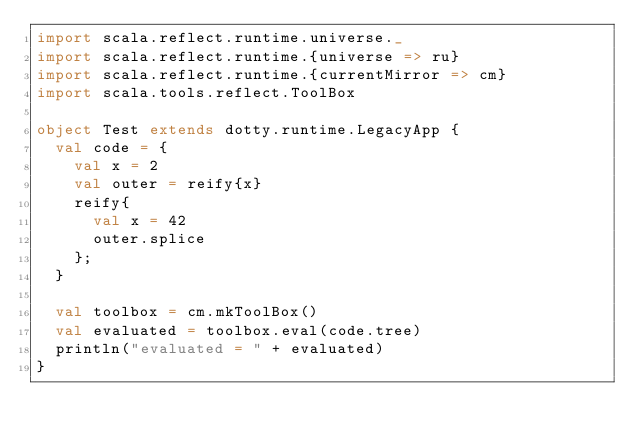Convert code to text. <code><loc_0><loc_0><loc_500><loc_500><_Scala_>import scala.reflect.runtime.universe._
import scala.reflect.runtime.{universe => ru}
import scala.reflect.runtime.{currentMirror => cm}
import scala.tools.reflect.ToolBox

object Test extends dotty.runtime.LegacyApp {
  val code = {
    val x = 2
    val outer = reify{x}
    reify{
      val x = 42
      outer.splice
    };
  }

  val toolbox = cm.mkToolBox()
  val evaluated = toolbox.eval(code.tree)
  println("evaluated = " + evaluated)
}
</code> 